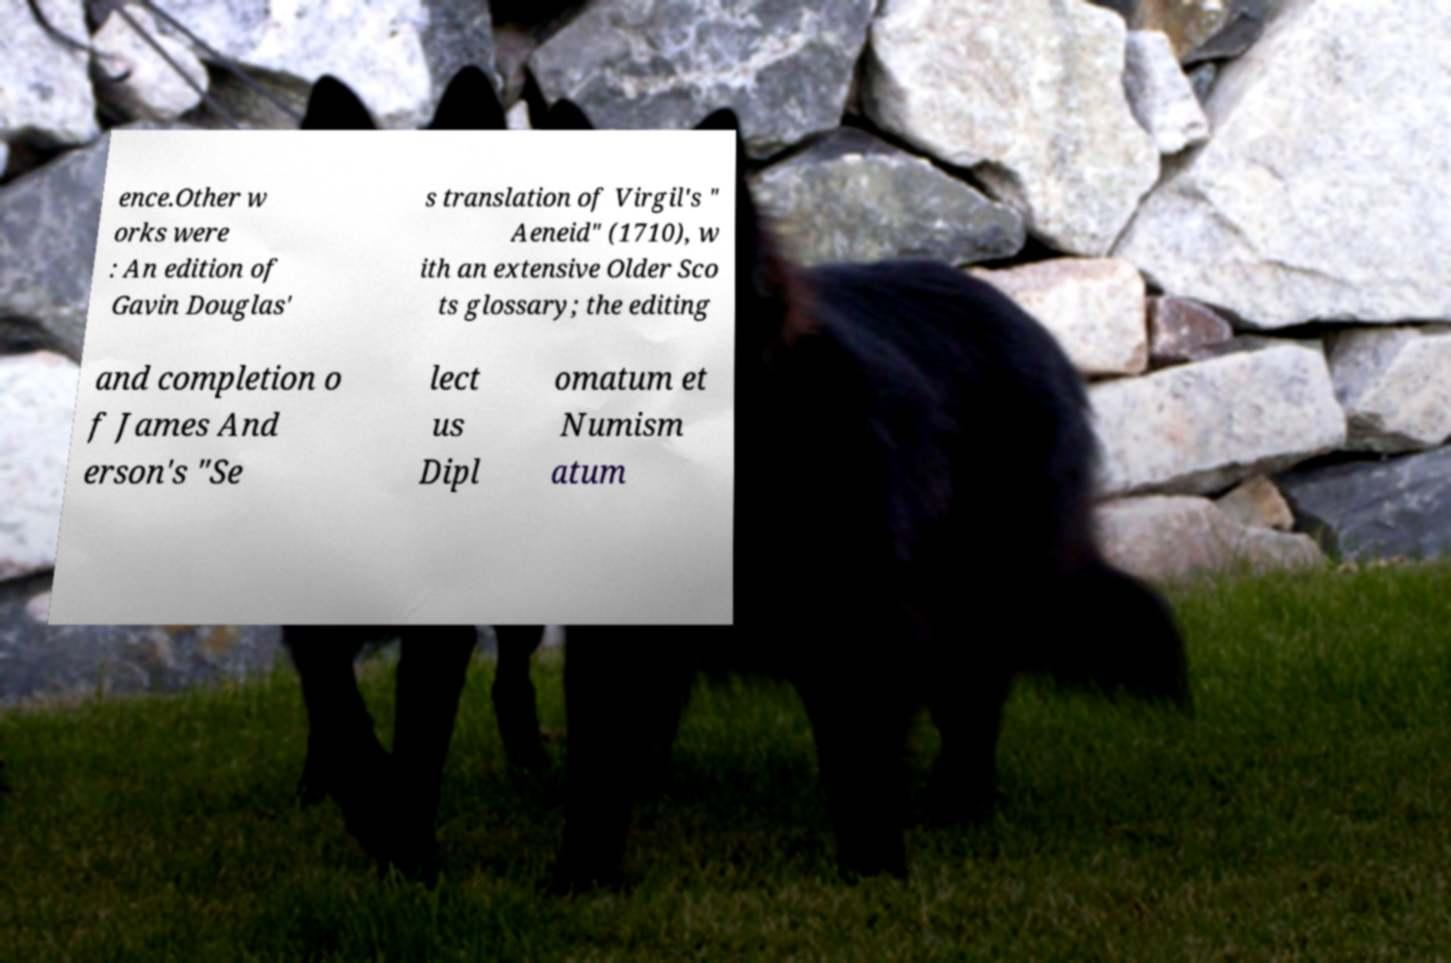What messages or text are displayed in this image? I need them in a readable, typed format. ence.Other w orks were : An edition of Gavin Douglas' s translation of Virgil's " Aeneid" (1710), w ith an extensive Older Sco ts glossary; the editing and completion o f James And erson's "Se lect us Dipl omatum et Numism atum 